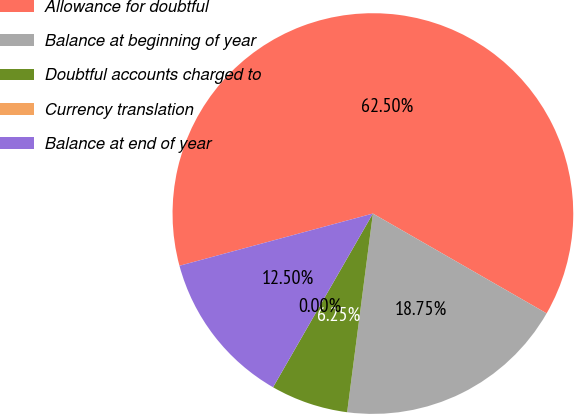<chart> <loc_0><loc_0><loc_500><loc_500><pie_chart><fcel>Allowance for doubtful<fcel>Balance at beginning of year<fcel>Doubtful accounts charged to<fcel>Currency translation<fcel>Balance at end of year<nl><fcel>62.49%<fcel>18.75%<fcel>6.25%<fcel>0.0%<fcel>12.5%<nl></chart> 